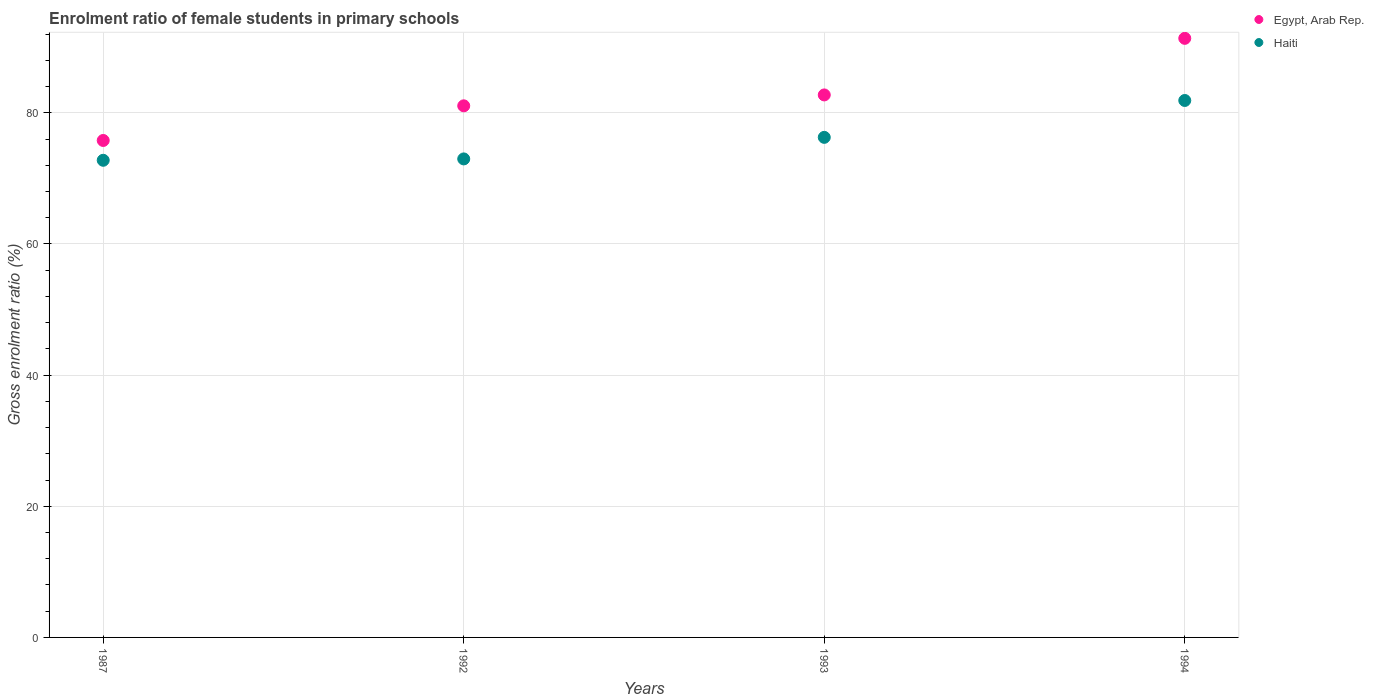Is the number of dotlines equal to the number of legend labels?
Make the answer very short. Yes. What is the enrolment ratio of female students in primary schools in Haiti in 1992?
Your answer should be very brief. 72.97. Across all years, what is the maximum enrolment ratio of female students in primary schools in Egypt, Arab Rep.?
Ensure brevity in your answer.  91.36. Across all years, what is the minimum enrolment ratio of female students in primary schools in Haiti?
Offer a terse response. 72.76. In which year was the enrolment ratio of female students in primary schools in Haiti maximum?
Provide a succinct answer. 1994. What is the total enrolment ratio of female students in primary schools in Haiti in the graph?
Your response must be concise. 303.87. What is the difference between the enrolment ratio of female students in primary schools in Egypt, Arab Rep. in 1992 and that in 1993?
Offer a terse response. -1.66. What is the difference between the enrolment ratio of female students in primary schools in Haiti in 1993 and the enrolment ratio of female students in primary schools in Egypt, Arab Rep. in 1987?
Offer a terse response. 0.47. What is the average enrolment ratio of female students in primary schools in Egypt, Arab Rep. per year?
Your response must be concise. 82.73. In the year 1993, what is the difference between the enrolment ratio of female students in primary schools in Haiti and enrolment ratio of female students in primary schools in Egypt, Arab Rep.?
Provide a succinct answer. -6.47. In how many years, is the enrolment ratio of female students in primary schools in Egypt, Arab Rep. greater than 84 %?
Your answer should be very brief. 1. What is the ratio of the enrolment ratio of female students in primary schools in Egypt, Arab Rep. in 1992 to that in 1994?
Keep it short and to the point. 0.89. Is the enrolment ratio of female students in primary schools in Haiti in 1992 less than that in 1993?
Ensure brevity in your answer.  Yes. Is the difference between the enrolment ratio of female students in primary schools in Haiti in 1987 and 1992 greater than the difference between the enrolment ratio of female students in primary schools in Egypt, Arab Rep. in 1987 and 1992?
Your answer should be compact. Yes. What is the difference between the highest and the second highest enrolment ratio of female students in primary schools in Egypt, Arab Rep.?
Give a very brief answer. 8.63. What is the difference between the highest and the lowest enrolment ratio of female students in primary schools in Haiti?
Provide a short and direct response. 9.12. In how many years, is the enrolment ratio of female students in primary schools in Haiti greater than the average enrolment ratio of female students in primary schools in Haiti taken over all years?
Ensure brevity in your answer.  2. Is the enrolment ratio of female students in primary schools in Egypt, Arab Rep. strictly less than the enrolment ratio of female students in primary schools in Haiti over the years?
Make the answer very short. No. How many dotlines are there?
Your answer should be compact. 2. Are the values on the major ticks of Y-axis written in scientific E-notation?
Your response must be concise. No. Does the graph contain grids?
Give a very brief answer. Yes. Where does the legend appear in the graph?
Keep it short and to the point. Top right. How many legend labels are there?
Provide a short and direct response. 2. What is the title of the graph?
Provide a short and direct response. Enrolment ratio of female students in primary schools. Does "Netherlands" appear as one of the legend labels in the graph?
Make the answer very short. No. What is the label or title of the Y-axis?
Keep it short and to the point. Gross enrolment ratio (%). What is the Gross enrolment ratio (%) in Egypt, Arab Rep. in 1987?
Your answer should be compact. 75.78. What is the Gross enrolment ratio (%) in Haiti in 1987?
Make the answer very short. 72.76. What is the Gross enrolment ratio (%) of Egypt, Arab Rep. in 1992?
Give a very brief answer. 81.07. What is the Gross enrolment ratio (%) of Haiti in 1992?
Ensure brevity in your answer.  72.97. What is the Gross enrolment ratio (%) in Egypt, Arab Rep. in 1993?
Keep it short and to the point. 82.73. What is the Gross enrolment ratio (%) in Haiti in 1993?
Your response must be concise. 76.26. What is the Gross enrolment ratio (%) of Egypt, Arab Rep. in 1994?
Keep it short and to the point. 91.36. What is the Gross enrolment ratio (%) in Haiti in 1994?
Your answer should be compact. 81.88. Across all years, what is the maximum Gross enrolment ratio (%) of Egypt, Arab Rep.?
Your answer should be very brief. 91.36. Across all years, what is the maximum Gross enrolment ratio (%) in Haiti?
Your answer should be compact. 81.88. Across all years, what is the minimum Gross enrolment ratio (%) in Egypt, Arab Rep.?
Make the answer very short. 75.78. Across all years, what is the minimum Gross enrolment ratio (%) in Haiti?
Keep it short and to the point. 72.76. What is the total Gross enrolment ratio (%) in Egypt, Arab Rep. in the graph?
Provide a succinct answer. 330.93. What is the total Gross enrolment ratio (%) of Haiti in the graph?
Keep it short and to the point. 303.87. What is the difference between the Gross enrolment ratio (%) in Egypt, Arab Rep. in 1987 and that in 1992?
Make the answer very short. -5.28. What is the difference between the Gross enrolment ratio (%) in Haiti in 1987 and that in 1992?
Provide a short and direct response. -0.21. What is the difference between the Gross enrolment ratio (%) of Egypt, Arab Rep. in 1987 and that in 1993?
Keep it short and to the point. -6.94. What is the difference between the Gross enrolment ratio (%) of Haiti in 1987 and that in 1993?
Make the answer very short. -3.5. What is the difference between the Gross enrolment ratio (%) of Egypt, Arab Rep. in 1987 and that in 1994?
Make the answer very short. -15.57. What is the difference between the Gross enrolment ratio (%) of Haiti in 1987 and that in 1994?
Ensure brevity in your answer.  -9.12. What is the difference between the Gross enrolment ratio (%) in Egypt, Arab Rep. in 1992 and that in 1993?
Your answer should be compact. -1.66. What is the difference between the Gross enrolment ratio (%) in Haiti in 1992 and that in 1993?
Provide a succinct answer. -3.29. What is the difference between the Gross enrolment ratio (%) of Egypt, Arab Rep. in 1992 and that in 1994?
Your answer should be very brief. -10.29. What is the difference between the Gross enrolment ratio (%) in Haiti in 1992 and that in 1994?
Offer a very short reply. -8.91. What is the difference between the Gross enrolment ratio (%) of Egypt, Arab Rep. in 1993 and that in 1994?
Ensure brevity in your answer.  -8.63. What is the difference between the Gross enrolment ratio (%) in Haiti in 1993 and that in 1994?
Your response must be concise. -5.62. What is the difference between the Gross enrolment ratio (%) of Egypt, Arab Rep. in 1987 and the Gross enrolment ratio (%) of Haiti in 1992?
Offer a terse response. 2.81. What is the difference between the Gross enrolment ratio (%) of Egypt, Arab Rep. in 1987 and the Gross enrolment ratio (%) of Haiti in 1993?
Provide a succinct answer. -0.47. What is the difference between the Gross enrolment ratio (%) in Egypt, Arab Rep. in 1987 and the Gross enrolment ratio (%) in Haiti in 1994?
Offer a terse response. -6.1. What is the difference between the Gross enrolment ratio (%) of Egypt, Arab Rep. in 1992 and the Gross enrolment ratio (%) of Haiti in 1993?
Keep it short and to the point. 4.81. What is the difference between the Gross enrolment ratio (%) of Egypt, Arab Rep. in 1992 and the Gross enrolment ratio (%) of Haiti in 1994?
Keep it short and to the point. -0.81. What is the difference between the Gross enrolment ratio (%) in Egypt, Arab Rep. in 1993 and the Gross enrolment ratio (%) in Haiti in 1994?
Provide a succinct answer. 0.85. What is the average Gross enrolment ratio (%) of Egypt, Arab Rep. per year?
Offer a very short reply. 82.73. What is the average Gross enrolment ratio (%) of Haiti per year?
Offer a terse response. 75.97. In the year 1987, what is the difference between the Gross enrolment ratio (%) in Egypt, Arab Rep. and Gross enrolment ratio (%) in Haiti?
Make the answer very short. 3.02. In the year 1992, what is the difference between the Gross enrolment ratio (%) in Egypt, Arab Rep. and Gross enrolment ratio (%) in Haiti?
Provide a short and direct response. 8.1. In the year 1993, what is the difference between the Gross enrolment ratio (%) of Egypt, Arab Rep. and Gross enrolment ratio (%) of Haiti?
Your answer should be compact. 6.47. In the year 1994, what is the difference between the Gross enrolment ratio (%) in Egypt, Arab Rep. and Gross enrolment ratio (%) in Haiti?
Keep it short and to the point. 9.48. What is the ratio of the Gross enrolment ratio (%) in Egypt, Arab Rep. in 1987 to that in 1992?
Your response must be concise. 0.93. What is the ratio of the Gross enrolment ratio (%) of Egypt, Arab Rep. in 1987 to that in 1993?
Offer a very short reply. 0.92. What is the ratio of the Gross enrolment ratio (%) of Haiti in 1987 to that in 1993?
Your answer should be compact. 0.95. What is the ratio of the Gross enrolment ratio (%) of Egypt, Arab Rep. in 1987 to that in 1994?
Offer a very short reply. 0.83. What is the ratio of the Gross enrolment ratio (%) of Haiti in 1987 to that in 1994?
Your response must be concise. 0.89. What is the ratio of the Gross enrolment ratio (%) of Egypt, Arab Rep. in 1992 to that in 1993?
Ensure brevity in your answer.  0.98. What is the ratio of the Gross enrolment ratio (%) of Haiti in 1992 to that in 1993?
Provide a short and direct response. 0.96. What is the ratio of the Gross enrolment ratio (%) in Egypt, Arab Rep. in 1992 to that in 1994?
Provide a succinct answer. 0.89. What is the ratio of the Gross enrolment ratio (%) of Haiti in 1992 to that in 1994?
Give a very brief answer. 0.89. What is the ratio of the Gross enrolment ratio (%) of Egypt, Arab Rep. in 1993 to that in 1994?
Your answer should be very brief. 0.91. What is the ratio of the Gross enrolment ratio (%) in Haiti in 1993 to that in 1994?
Give a very brief answer. 0.93. What is the difference between the highest and the second highest Gross enrolment ratio (%) of Egypt, Arab Rep.?
Offer a terse response. 8.63. What is the difference between the highest and the second highest Gross enrolment ratio (%) in Haiti?
Provide a succinct answer. 5.62. What is the difference between the highest and the lowest Gross enrolment ratio (%) of Egypt, Arab Rep.?
Your answer should be very brief. 15.57. What is the difference between the highest and the lowest Gross enrolment ratio (%) of Haiti?
Keep it short and to the point. 9.12. 